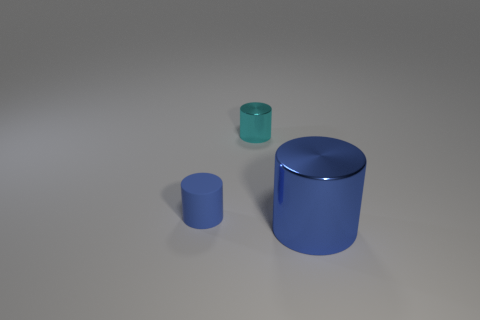Subtract all metal cylinders. How many cylinders are left? 1 Add 2 shiny cylinders. How many objects exist? 5 Subtract all cyan cylinders. How many cylinders are left? 2 Subtract 1 cylinders. How many cylinders are left? 2 Subtract all brown cylinders. Subtract all brown spheres. How many cylinders are left? 3 Subtract all gray blocks. How many yellow cylinders are left? 0 Subtract all big shiny objects. Subtract all big metallic cylinders. How many objects are left? 1 Add 2 small metal objects. How many small metal objects are left? 3 Add 3 large blue cylinders. How many large blue cylinders exist? 4 Subtract 0 gray cylinders. How many objects are left? 3 